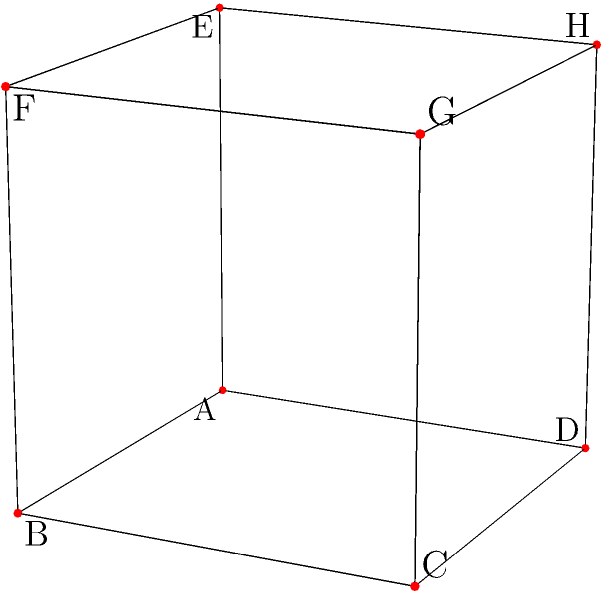A cube is shown from a specific perspective. If the cube is rotated 90 degrees clockwise around the vertical axis passing through vertices E and G, which vertex will be closest to the viewer? To solve this problem, let's follow these steps:

1. Identify the current orientation:
   - Vertex A is at the front-bottom-left corner
   - Vertex G is at the back-top-right corner

2. Understand the rotation:
   - The cube will rotate 90 degrees clockwise around the vertical axis passing through E and G
   - This axis goes from the top-left to the bottom-right of the cube in its current orientation

3. Visualize the rotation:
   - The front face (ABCD) will become the right face
   - The right face (BCGF) will become the back face
   - The back face (CGHD) will become the left face
   - The left face (ADHE) will become the front face

4. Determine the new front face:
   - After rotation, face ADHE will be in front

5. Identify the closest vertex:
   - Of the vertices on the new front face (ADHE), vertex D will be closest to the viewer as it will be at the front-top-right corner

Therefore, after the rotation, vertex D will be closest to the viewer.
Answer: D 